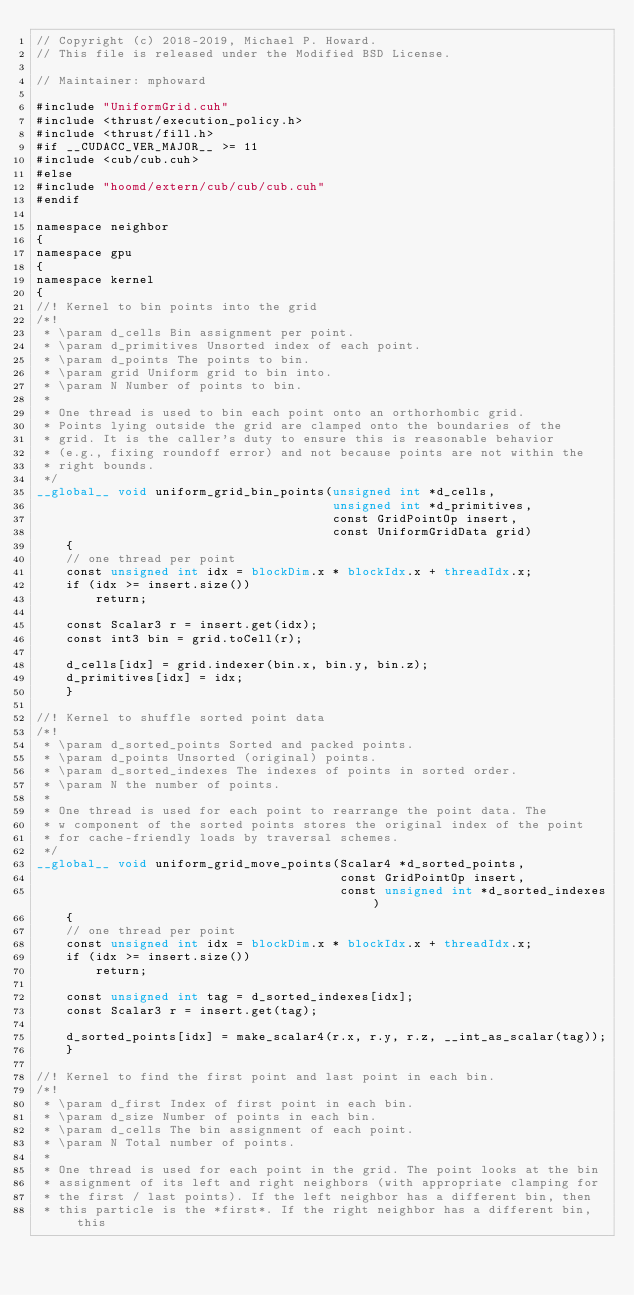<code> <loc_0><loc_0><loc_500><loc_500><_Cuda_>// Copyright (c) 2018-2019, Michael P. Howard.
// This file is released under the Modified BSD License.

// Maintainer: mphoward

#include "UniformGrid.cuh"
#include <thrust/execution_policy.h>
#include <thrust/fill.h>
#if __CUDACC_VER_MAJOR__ >= 11
#include <cub/cub.cuh>
#else
#include "hoomd/extern/cub/cub/cub.cuh"
#endif

namespace neighbor
{
namespace gpu
{
namespace kernel
{
//! Kernel to bin points into the grid
/*!
 * \param d_cells Bin assignment per point.
 * \param d_primitives Unsorted index of each point.
 * \param d_points The points to bin.
 * \param grid Uniform grid to bin into.
 * \param N Number of points to bin.
 *
 * One thread is used to bin each point onto an orthorhombic grid.
 * Points lying outside the grid are clamped onto the boundaries of the
 * grid. It is the caller's duty to ensure this is reasonable behavior
 * (e.g., fixing roundoff error) and not because points are not within the
 * right bounds.
 */
__global__ void uniform_grid_bin_points(unsigned int *d_cells,
                                        unsigned int *d_primitives,
                                        const GridPointOp insert,
                                        const UniformGridData grid)
    {
    // one thread per point
    const unsigned int idx = blockDim.x * blockIdx.x + threadIdx.x;
    if (idx >= insert.size())
        return;

    const Scalar3 r = insert.get(idx);
    const int3 bin = grid.toCell(r);

    d_cells[idx] = grid.indexer(bin.x, bin.y, bin.z);
    d_primitives[idx] = idx;
    }

//! Kernel to shuffle sorted point data
/*!
 * \param d_sorted_points Sorted and packed points.
 * \param d_points Unsorted (original) points.
 * \param d_sorted_indexes The indexes of points in sorted order.
 * \param N the number of points.
 *
 * One thread is used for each point to rearrange the point data. The
 * w component of the sorted points stores the original index of the point
 * for cache-friendly loads by traversal schemes.
 */
__global__ void uniform_grid_move_points(Scalar4 *d_sorted_points,
                                         const GridPointOp insert,
                                         const unsigned int *d_sorted_indexes)
    {
    // one thread per point
    const unsigned int idx = blockDim.x * blockIdx.x + threadIdx.x;
    if (idx >= insert.size())
        return;

    const unsigned int tag = d_sorted_indexes[idx];
    const Scalar3 r = insert.get(tag);

    d_sorted_points[idx] = make_scalar4(r.x, r.y, r.z, __int_as_scalar(tag));
    }

//! Kernel to find the first point and last point in each bin.
/*!
 * \param d_first Index of first point in each bin.
 * \param d_size Number of points in each bin.
 * \param d_cells The bin assignment of each point.
 * \param N Total number of points.
 *
 * One thread is used for each point in the grid. The point looks at the bin
 * assignment of its left and right neighbors (with appropriate clamping for
 * the first / last points). If the left neighbor has a different bin, then
 * this particle is the *first*. If the right neighbor has a different bin, this</code> 